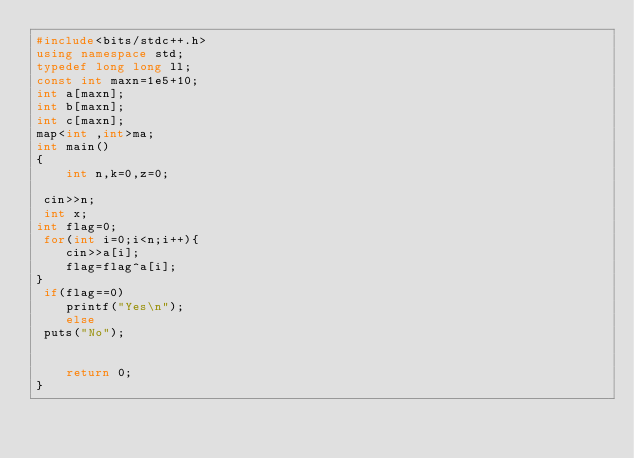Convert code to text. <code><loc_0><loc_0><loc_500><loc_500><_C++_>#include<bits/stdc++.h>
using namespace std;
typedef long long ll;
const int maxn=1e5+10;
int a[maxn];
int b[maxn];
int c[maxn];
map<int ,int>ma;
int main()
{
    int n,k=0,z=0;

 cin>>n;
 int x;
int flag=0;
 for(int i=0;i<n;i++){
    cin>>a[i];
    flag=flag^a[i];
}
 if(flag==0)
    printf("Yes\n");
    else
 puts("No");


    return 0;
}
</code> 